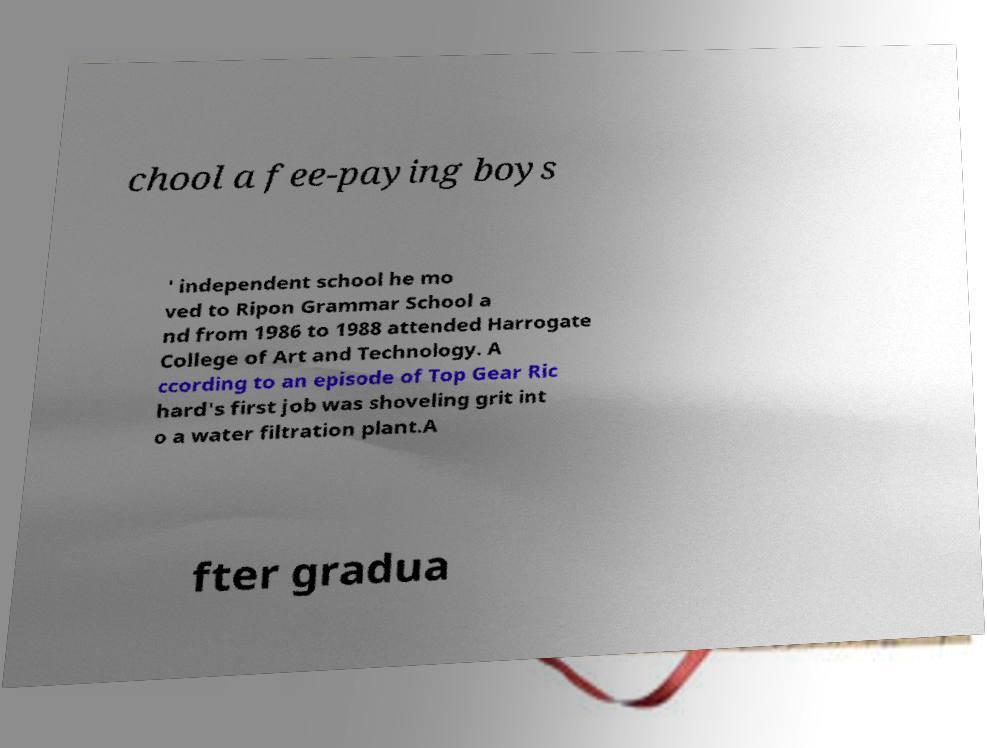Could you extract and type out the text from this image? chool a fee-paying boys ' independent school he mo ved to Ripon Grammar School a nd from 1986 to 1988 attended Harrogate College of Art and Technology. A ccording to an episode of Top Gear Ric hard's first job was shoveling grit int o a water filtration plant.A fter gradua 